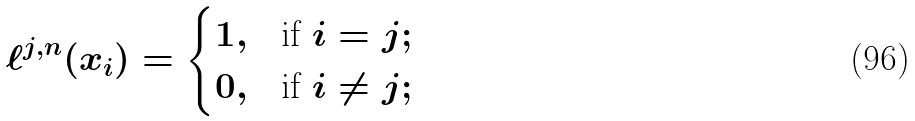<formula> <loc_0><loc_0><loc_500><loc_500>\ell ^ { j , n } ( x _ { i } ) = \begin{cases} 1 , & \text {if} \ i = j ; \\ 0 , & \text {if} \ i \neq j ; \end{cases}</formula> 